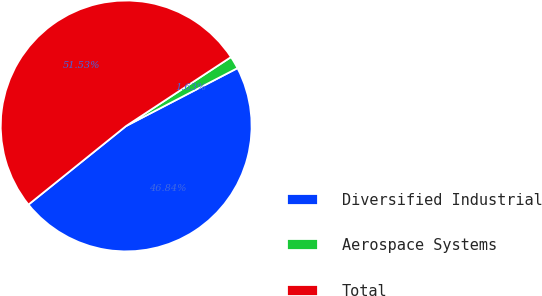<chart> <loc_0><loc_0><loc_500><loc_500><pie_chart><fcel>Diversified Industrial<fcel>Aerospace Systems<fcel>Total<nl><fcel>46.84%<fcel>1.63%<fcel>51.53%<nl></chart> 